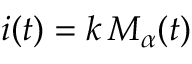<formula> <loc_0><loc_0><loc_500><loc_500>i ( t ) = k \, M _ { \alpha } ( t )</formula> 